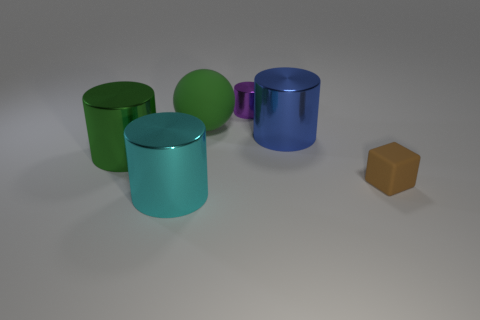Add 2 large green cylinders. How many objects exist? 8 Subtract all balls. How many objects are left? 5 Subtract 1 green cylinders. How many objects are left? 5 Subtract all tiny metal objects. Subtract all matte balls. How many objects are left? 4 Add 1 green spheres. How many green spheres are left? 2 Add 1 brown cubes. How many brown cubes exist? 2 